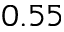<formula> <loc_0><loc_0><loc_500><loc_500>0 . 5 5</formula> 